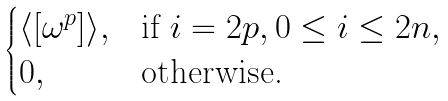Convert formula to latex. <formula><loc_0><loc_0><loc_500><loc_500>\begin{cases} \langle [ \omega ^ { p } ] \rangle , & \text {if } i = 2 p , 0 \leq i \leq 2 n , \\ 0 , & \text {otherwise.} \end{cases}</formula> 